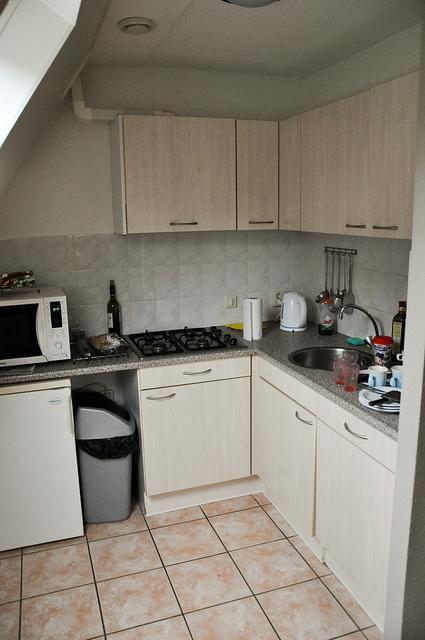How many black backpacks are seen?
Give a very brief answer. 0. 